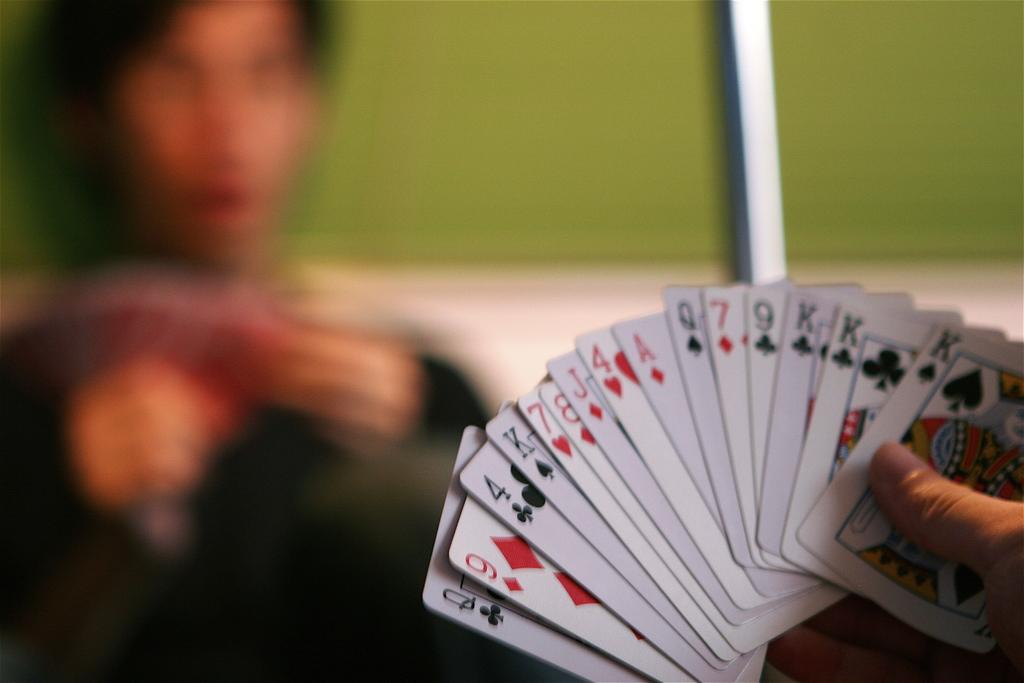What is the person in the image holding? The person is holding cards in the image. Can you describe the background of the image? The background of the image is blurred. How many people are present in the image? There is one person present in the image. What type of worm can be seen crawling on the cards in the image? There is no worm present in the image; the person is holding cards without any visible worms. 